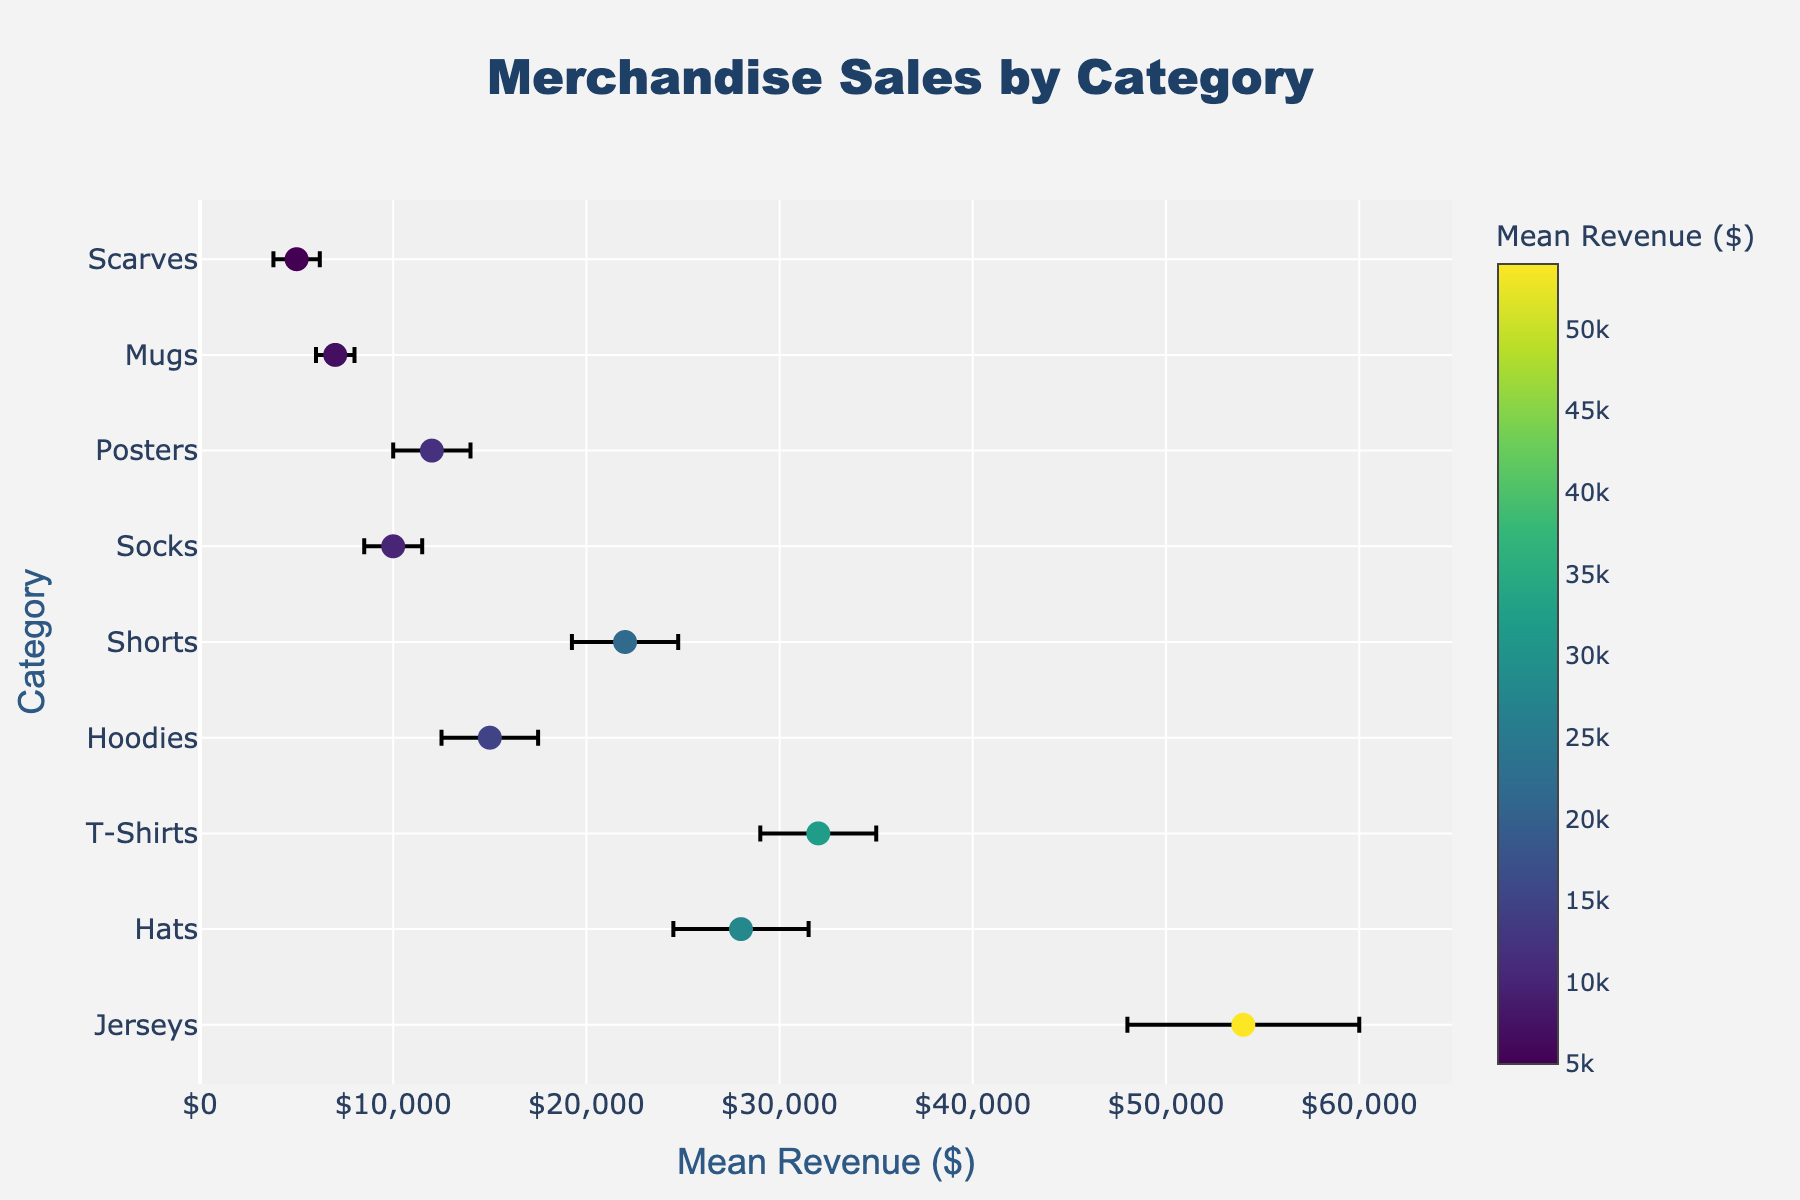what is the category with the highest mean revenue? The figure shows the mean revenue on the x-axis and the category on the y-axis. By observing the dot that is farthest right on the x-axis, we can see that "Jerseys" has the highest mean revenue.
Answer: Jerseys which category has the lowest mean revenue? Look for the dot that is farthest left on the x-axis, indicating the lowest mean revenue. The category with the lowest mean revenue is "Scarves."
Answer: Scarves what is the mean revenue for T-Shirts? Locate the dot corresponding to "T-Shirts" on the y-axis. Follow its position on the x-axis to determine its mean revenue, which is 32,000.
Answer: $32,000 how does the revenue variance of Hats compare to that of Hoodies? Check the length of the error bars associated with the "Hats" and "Hoodies" categories. Hats has an error bar length of 3,500, while Hoodies has an error bar length of 2,500, indicating that Hats has a larger revenue variance.
Answer: Hats has a larger revenue variance which category is more consistent in revenue: Posters or Mugs? Consistency in revenue is indicated by shorter error bars. By comparing the length of the error bars for "Posters" and "Mugs," we see that Posters has a longer error bar (2,000) compared to Mugs (1,000), meaning Mugs is more consistent.
Answer: Mugs what is the mean revenue range covered by Hoodies? The mean revenue for Hoodies is 15,000 with a variance of 2,500. The range is calculated as mean revenue +/- variance. Therefore, the range is from 12,500 to 17,500.
Answer: $12,500 to $17,500 compare the mean revenues of Shorts and Socks. The mean revenue for Shorts is 22,000, and the mean revenue for Socks is 10,000. Therefore, Shorts has a higher mean revenue compared to Socks.
Answer: Shorts has higher mean revenue what does the color scale represent in the figure? The color scale to the right of the figure is labeled "Mean Revenue ($)," indicating that the color of each dot represents its associated mean revenue, with different colors showing different revenue levels.
Answer: Mean Revenue ($) how much greater is the mean revenue for Jerseys compared to Hats? The mean revenue for Jerseys is 54,000, and the mean revenue for Hats is 28,000. The difference is 54,000 - 28,000 = 26,000.
Answer: $26,000 